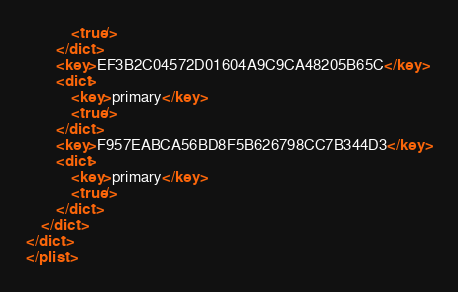Convert code to text. <code><loc_0><loc_0><loc_500><loc_500><_XML_>			<true/>
		</dict>
		<key>EF3B2C04572D01604A9C9CA48205B65C</key>
		<dict>
			<key>primary</key>
			<true/>
		</dict>
		<key>F957EABCA56BD8F5B626798CC7B344D3</key>
		<dict>
			<key>primary</key>
			<true/>
		</dict>
	</dict>
</dict>
</plist>
</code> 